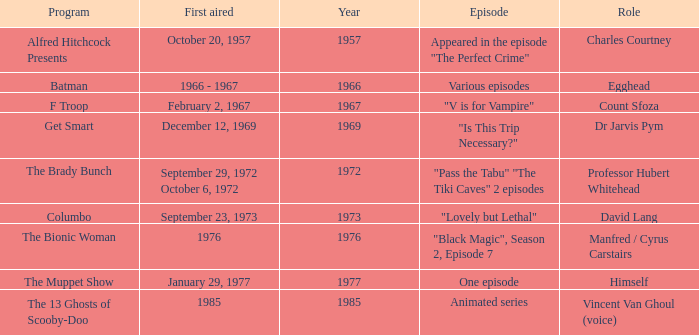What's the episode of Batman? Various episodes. 